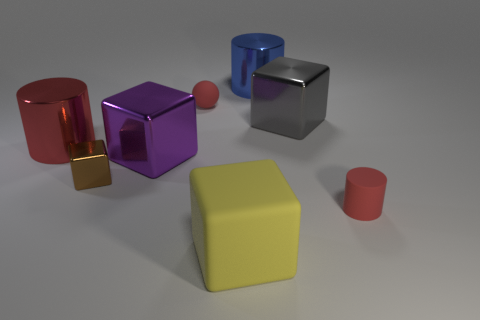Is there another large blue thing of the same shape as the big blue thing?
Your response must be concise. No. What number of large cubes are there?
Provide a short and direct response. 3. Is the material of the red cylinder behind the small brown cube the same as the big purple object?
Your response must be concise. Yes. Are there any red matte things of the same size as the brown metal cube?
Offer a terse response. Yes. Does the brown metallic thing have the same shape as the red rubber object that is behind the tiny red rubber cylinder?
Provide a succinct answer. No. Are there any tiny rubber cylinders on the right side of the tiny red rubber object that is on the right side of the big rubber object in front of the large red cylinder?
Offer a terse response. No. The brown thing is what size?
Ensure brevity in your answer.  Small. How many other objects are the same color as the big rubber block?
Provide a succinct answer. 0. There is a red matte thing behind the big red object; is its shape the same as the large blue metal thing?
Your response must be concise. No. There is another big metallic object that is the same shape as the purple object; what is its color?
Provide a succinct answer. Gray. 